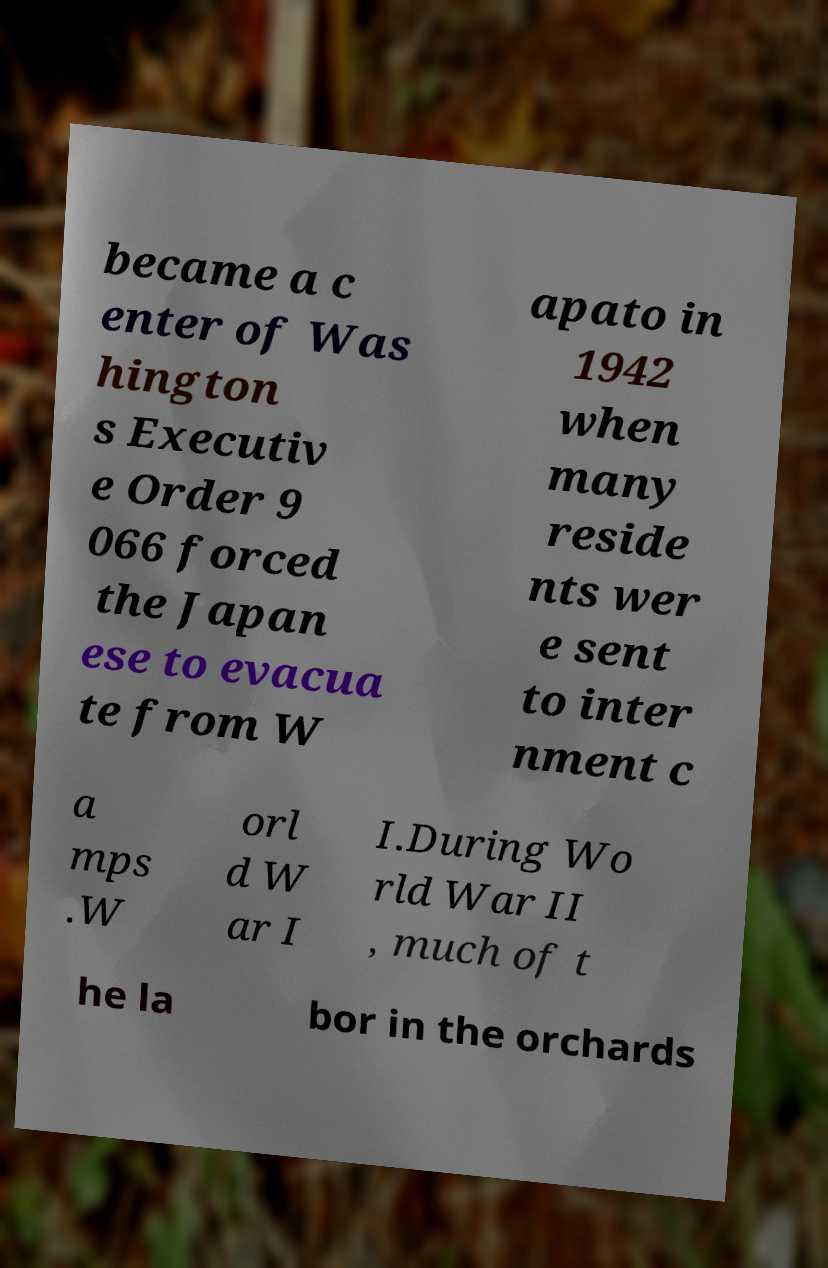There's text embedded in this image that I need extracted. Can you transcribe it verbatim? became a c enter of Was hington s Executiv e Order 9 066 forced the Japan ese to evacua te from W apato in 1942 when many reside nts wer e sent to inter nment c a mps .W orl d W ar I I.During Wo rld War II , much of t he la bor in the orchards 